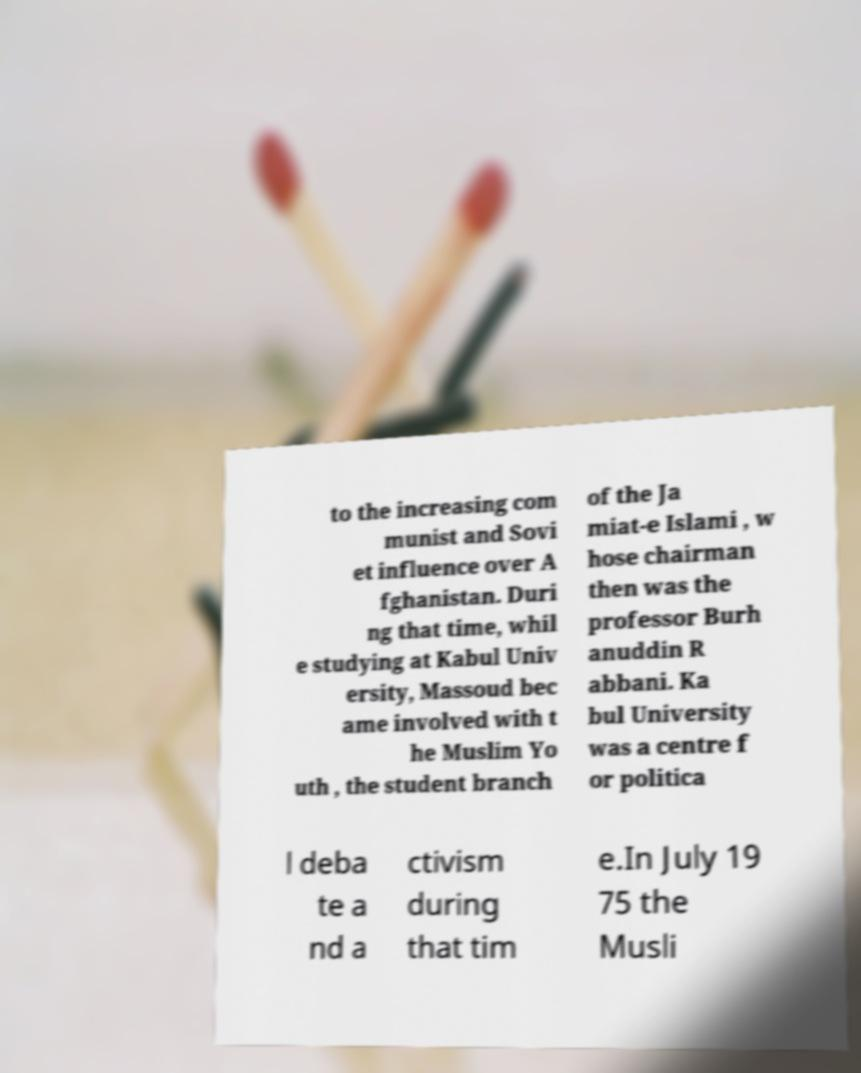Can you accurately transcribe the text from the provided image for me? to the increasing com munist and Sovi et influence over A fghanistan. Duri ng that time, whil e studying at Kabul Univ ersity, Massoud bec ame involved with t he Muslim Yo uth , the student branch of the Ja miat-e Islami , w hose chairman then was the professor Burh anuddin R abbani. Ka bul University was a centre f or politica l deba te a nd a ctivism during that tim e.In July 19 75 the Musli 